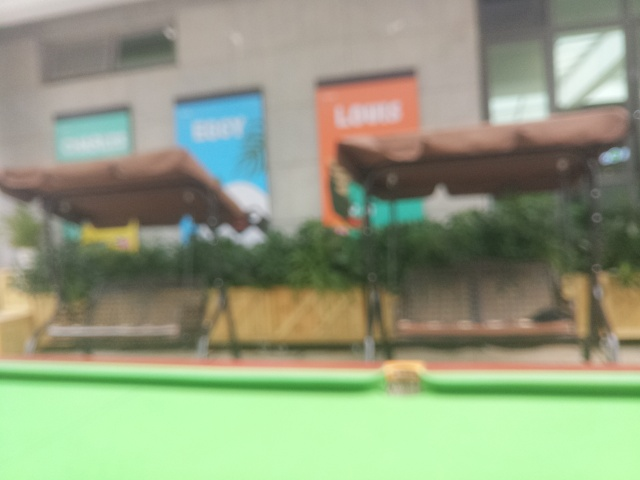What sort of improvements could be made to enhance the clarity of this image? Improving this image’s clarity could involve several techniques such as adjusting the sharpness settings, using noise reduction tools, or potentially taking a new photo with a steadier hand or better lighting conditions to reduce blurriness. 